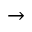<formula> <loc_0><loc_0><loc_500><loc_500>\rightarrow</formula> 